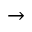<formula> <loc_0><loc_0><loc_500><loc_500>\rightarrow</formula> 